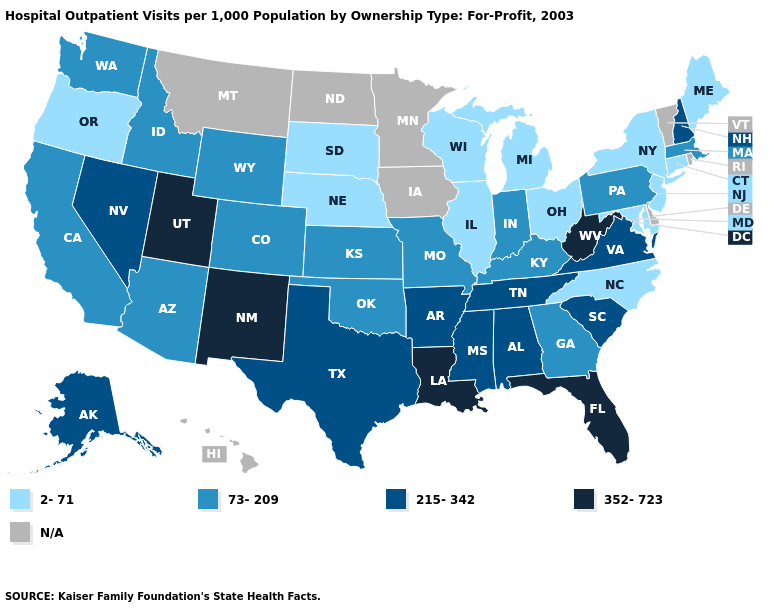What is the value of Connecticut?
Short answer required. 2-71. Does Louisiana have the highest value in the South?
Give a very brief answer. Yes. Does New York have the lowest value in the Northeast?
Answer briefly. Yes. Does Oregon have the lowest value in the West?
Short answer required. Yes. Name the states that have a value in the range 2-71?
Short answer required. Connecticut, Illinois, Maine, Maryland, Michigan, Nebraska, New Jersey, New York, North Carolina, Ohio, Oregon, South Dakota, Wisconsin. Does the map have missing data?
Write a very short answer. Yes. Which states have the lowest value in the USA?
Short answer required. Connecticut, Illinois, Maine, Maryland, Michigan, Nebraska, New Jersey, New York, North Carolina, Ohio, Oregon, South Dakota, Wisconsin. Which states have the highest value in the USA?
Write a very short answer. Florida, Louisiana, New Mexico, Utah, West Virginia. Which states have the lowest value in the USA?
Short answer required. Connecticut, Illinois, Maine, Maryland, Michigan, Nebraska, New Jersey, New York, North Carolina, Ohio, Oregon, South Dakota, Wisconsin. What is the value of Rhode Island?
Write a very short answer. N/A. Does Utah have the highest value in the West?
Keep it brief. Yes. Does the map have missing data?
Keep it brief. Yes. What is the highest value in the South ?
Give a very brief answer. 352-723. Name the states that have a value in the range 73-209?
Concise answer only. Arizona, California, Colorado, Georgia, Idaho, Indiana, Kansas, Kentucky, Massachusetts, Missouri, Oklahoma, Pennsylvania, Washington, Wyoming. 